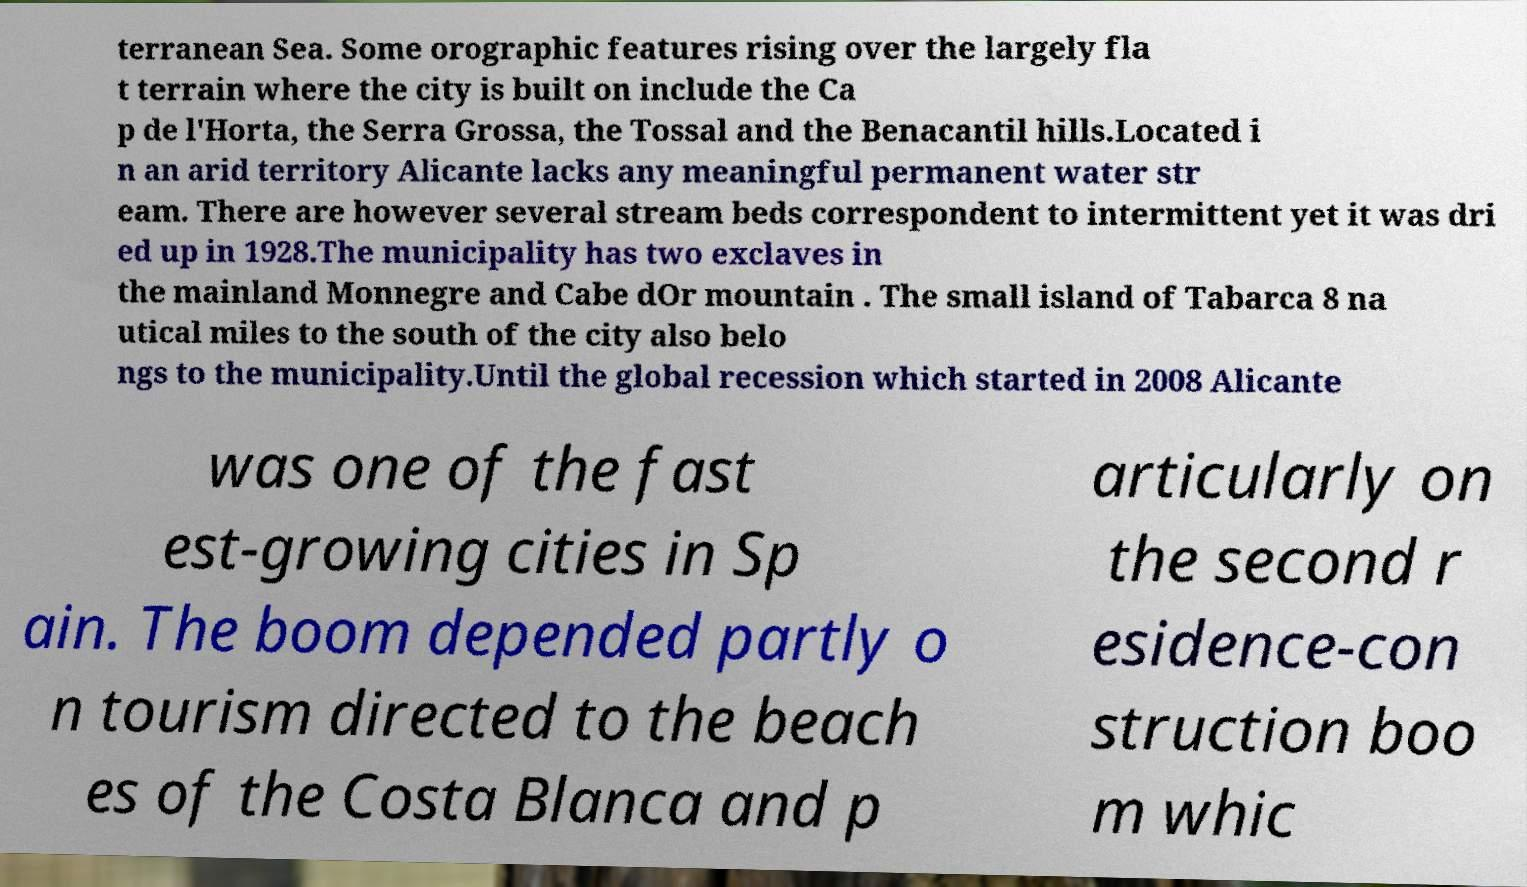Please identify and transcribe the text found in this image. terranean Sea. Some orographic features rising over the largely fla t terrain where the city is built on include the Ca p de l'Horta, the Serra Grossa, the Tossal and the Benacantil hills.Located i n an arid territory Alicante lacks any meaningful permanent water str eam. There are however several stream beds correspondent to intermittent yet it was dri ed up in 1928.The municipality has two exclaves in the mainland Monnegre and Cabe dOr mountain . The small island of Tabarca 8 na utical miles to the south of the city also belo ngs to the municipality.Until the global recession which started in 2008 Alicante was one of the fast est-growing cities in Sp ain. The boom depended partly o n tourism directed to the beach es of the Costa Blanca and p articularly on the second r esidence-con struction boo m whic 